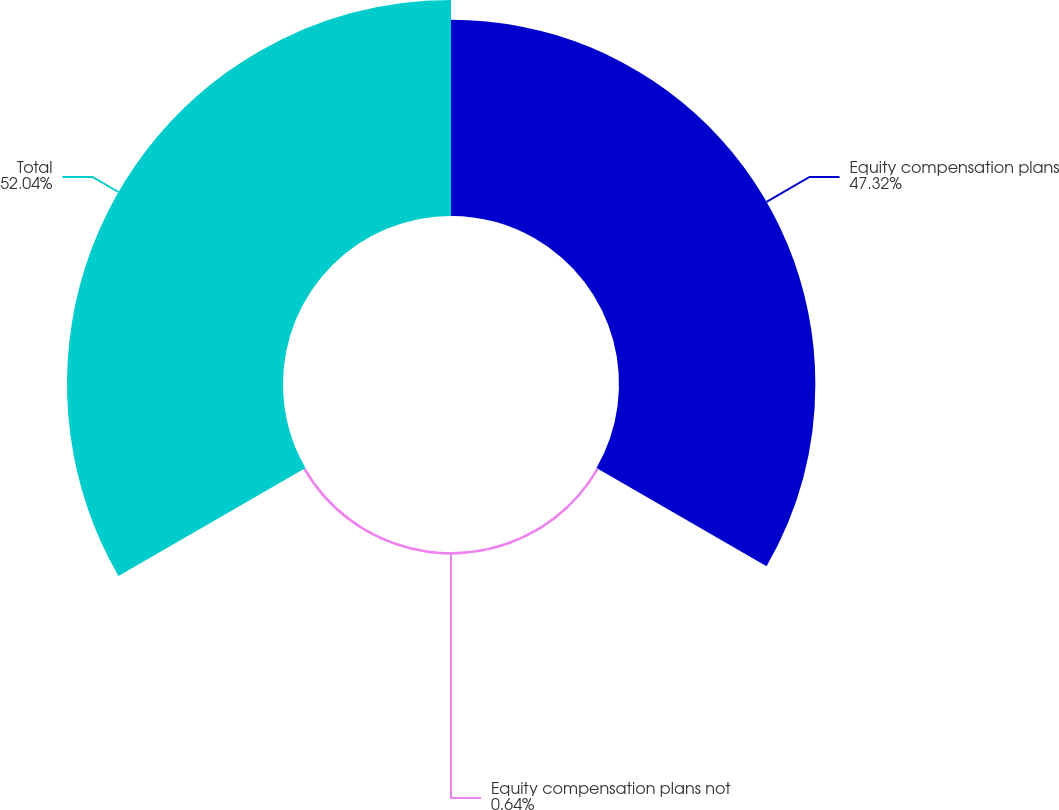<chart> <loc_0><loc_0><loc_500><loc_500><pie_chart><fcel>Equity compensation plans<fcel>Equity compensation plans not<fcel>Total<nl><fcel>47.32%<fcel>0.64%<fcel>52.05%<nl></chart> 